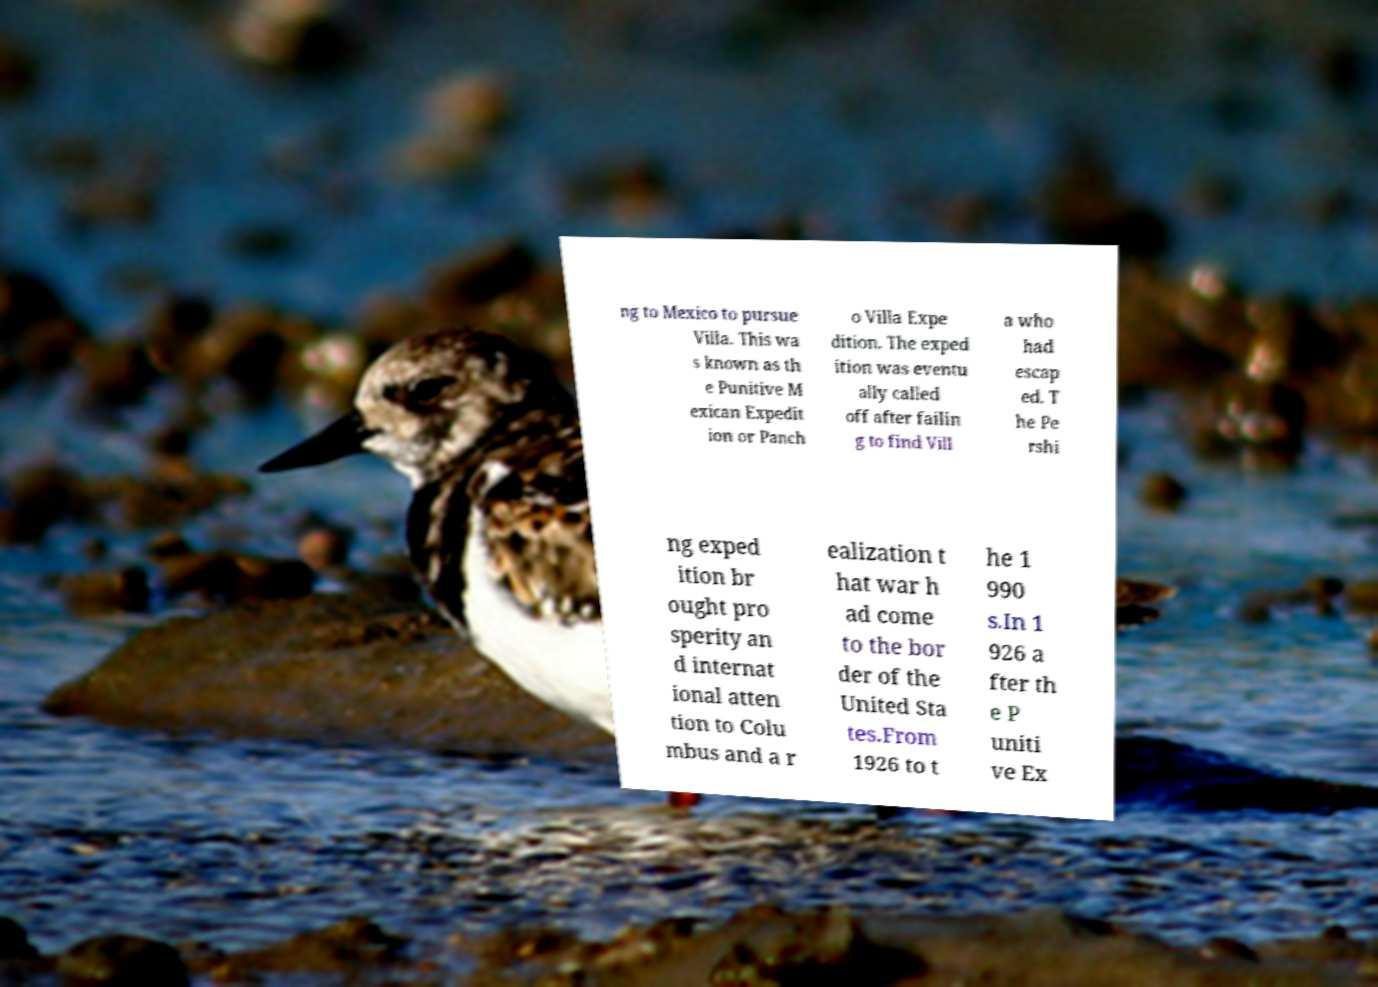Can you accurately transcribe the text from the provided image for me? ng to Mexico to pursue Villa. This wa s known as th e Punitive M exican Expedit ion or Panch o Villa Expe dition. The exped ition was eventu ally called off after failin g to find Vill a who had escap ed. T he Pe rshi ng exped ition br ought pro sperity an d internat ional atten tion to Colu mbus and a r ealization t hat war h ad come to the bor der of the United Sta tes.From 1926 to t he 1 990 s.In 1 926 a fter th e P uniti ve Ex 